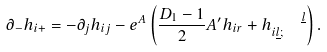Convert formula to latex. <formula><loc_0><loc_0><loc_500><loc_500>\partial _ { - } h _ { i + } = - \partial _ { j } h _ { i j } - e ^ { A } \left ( \frac { D _ { 1 } - 1 } { 2 } A ^ { \prime } h _ { i r } + h _ { i \underline { l } ; } ^ { \quad \underline { l } } \right ) .</formula> 